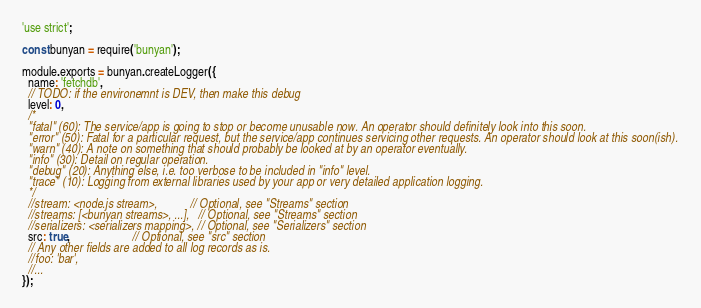<code> <loc_0><loc_0><loc_500><loc_500><_JavaScript_>'use strict';

const bunyan = require('bunyan');

module.exports = bunyan.createLogger({
  name: 'fetchdb',
  // TODO: if the environemnt is DEV, then make this debug
  level: 0,
  /*
  "fatal" (60): The service/app is going to stop or become unusable now. An operator should definitely look into this soon.
  "error" (50): Fatal for a particular request, but the service/app continues servicing other requests. An operator should look at this soon(ish).
  "warn" (40): A note on something that should probably be looked at by an operator eventually.
  "info" (30): Detail on regular operation.
  "debug" (20): Anything else, i.e. too verbose to be included in "info" level.
  "trace" (10): Logging from external libraries used by your app or very detailed application logging.
  */
  //stream: <node.js stream>,           // Optional, see "Streams" section
  //streams: [<bunyan streams>, ...],   // Optional, see "Streams" section
  //serializers: <serializers mapping>, // Optional, see "Serializers" section
  src: true,                     // Optional, see "src" section
  // Any other fields are added to all log records as is.
  //foo: 'bar',
  //...
});
</code> 